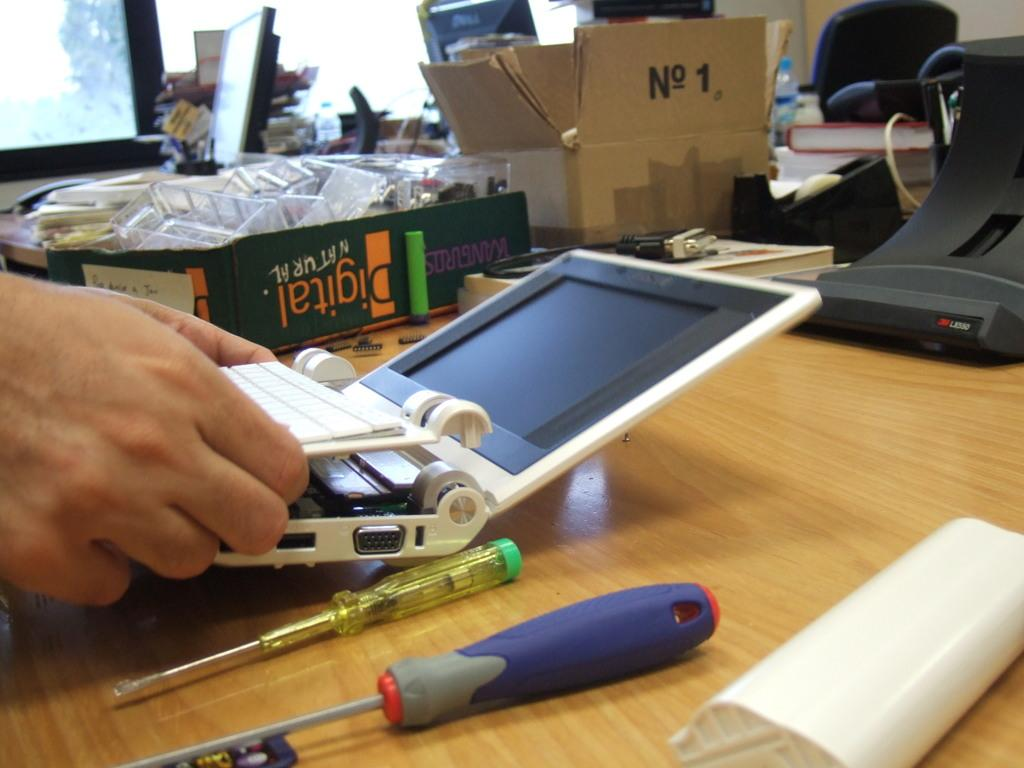<image>
Write a terse but informative summary of the picture. the number 1 is on the brown box on the table 